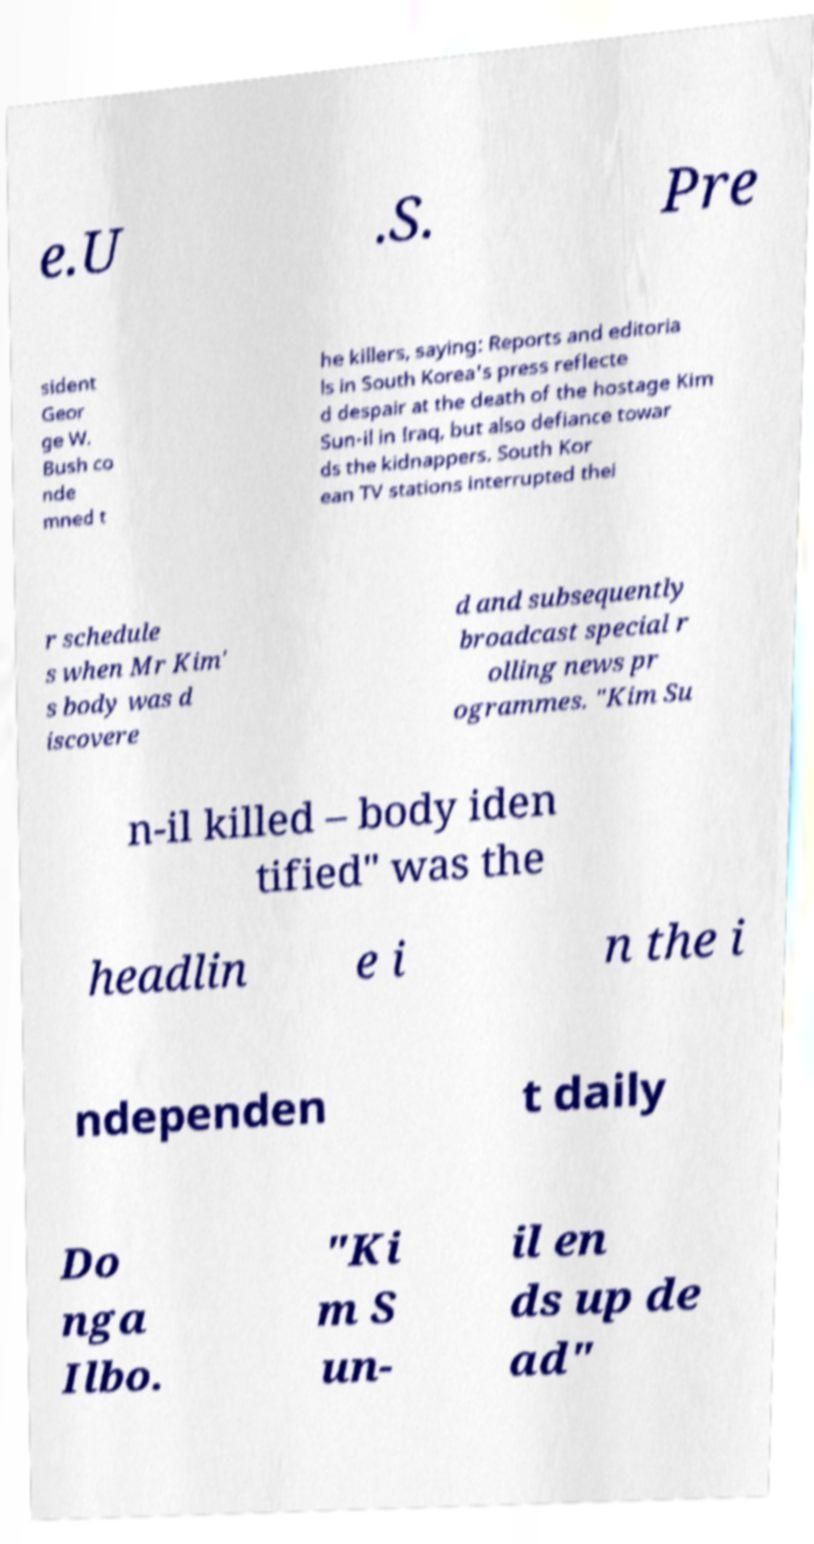Could you assist in decoding the text presented in this image and type it out clearly? e.U .S. Pre sident Geor ge W. Bush co nde mned t he killers, saying: Reports and editoria ls in South Korea's press reflecte d despair at the death of the hostage Kim Sun-il in Iraq, but also defiance towar ds the kidnappers. South Kor ean TV stations interrupted thei r schedule s when Mr Kim' s body was d iscovere d and subsequently broadcast special r olling news pr ogrammes. "Kim Su n-il killed – body iden tified" was the headlin e i n the i ndependen t daily Do nga Ilbo. "Ki m S un- il en ds up de ad" 